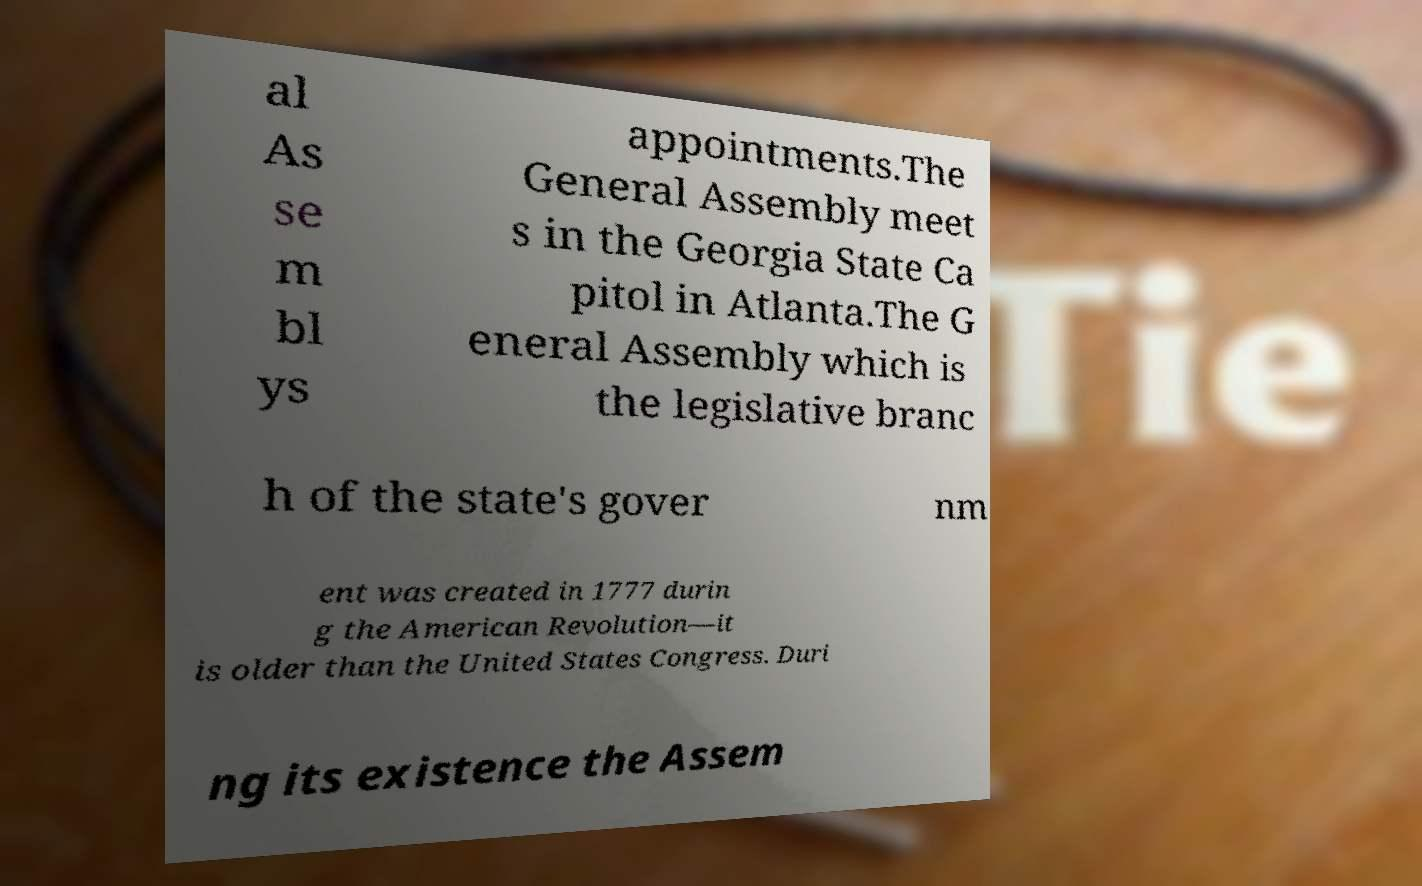Can you read and provide the text displayed in the image?This photo seems to have some interesting text. Can you extract and type it out for me? al As se m bl ys appointments.The General Assembly meet s in the Georgia State Ca pitol in Atlanta.The G eneral Assembly which is the legislative branc h of the state's gover nm ent was created in 1777 durin g the American Revolution—it is older than the United States Congress. Duri ng its existence the Assem 